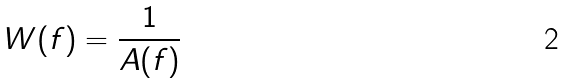<formula> <loc_0><loc_0><loc_500><loc_500>W ( f ) = \frac { 1 } { A ( f ) }</formula> 